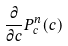<formula> <loc_0><loc_0><loc_500><loc_500>\frac { \partial } { \partial c } P _ { c } ^ { n } ( c )</formula> 